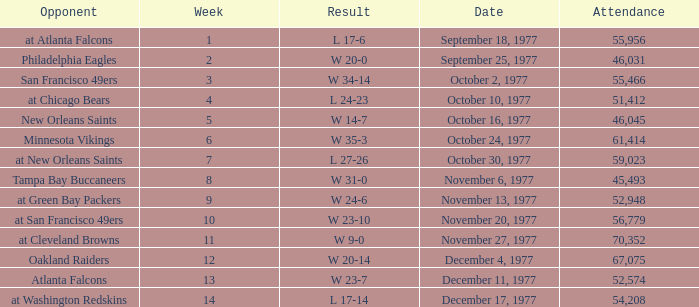What is the lowest attendance for week 2? 46031.0. 